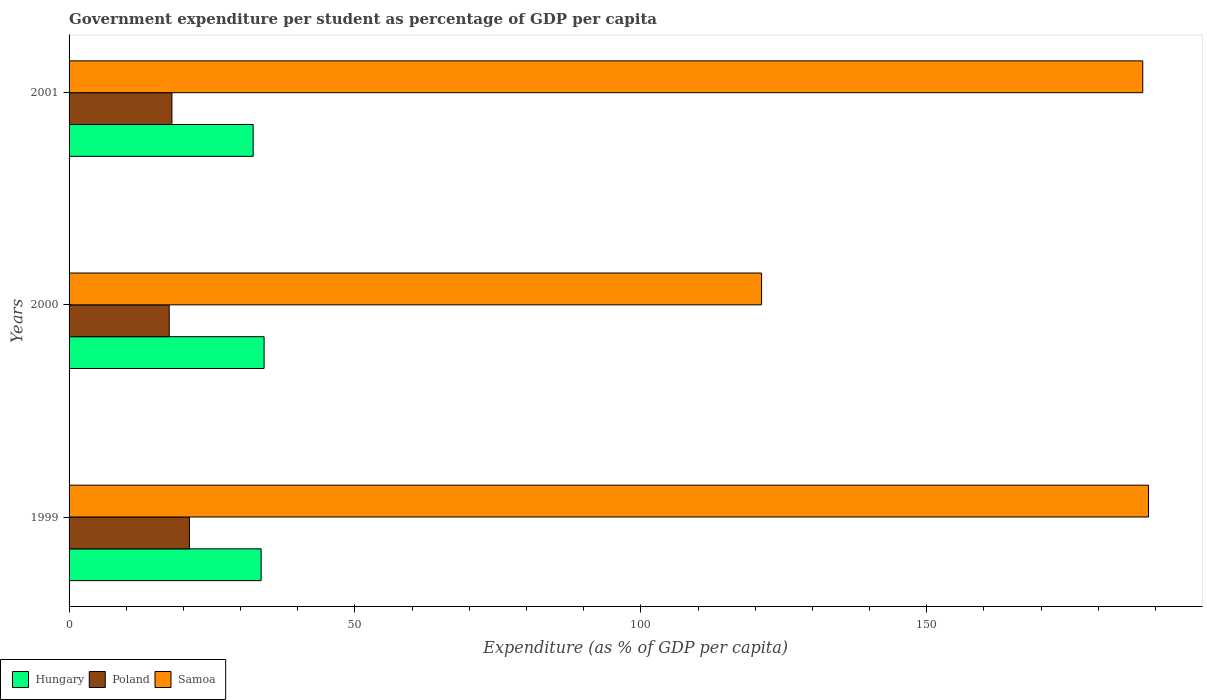Are the number of bars per tick equal to the number of legend labels?
Your answer should be compact. Yes. What is the percentage of expenditure per student in Poland in 2001?
Provide a succinct answer. 17.99. Across all years, what is the maximum percentage of expenditure per student in Hungary?
Offer a terse response. 34.11. Across all years, what is the minimum percentage of expenditure per student in Hungary?
Your answer should be compact. 32.2. In which year was the percentage of expenditure per student in Samoa maximum?
Ensure brevity in your answer.  1999. What is the total percentage of expenditure per student in Hungary in the graph?
Offer a very short reply. 99.89. What is the difference between the percentage of expenditure per student in Poland in 2000 and that in 2001?
Ensure brevity in your answer.  -0.48. What is the difference between the percentage of expenditure per student in Samoa in 2000 and the percentage of expenditure per student in Hungary in 1999?
Provide a short and direct response. 87.52. What is the average percentage of expenditure per student in Poland per year?
Provide a succinct answer. 18.85. In the year 2001, what is the difference between the percentage of expenditure per student in Hungary and percentage of expenditure per student in Poland?
Offer a terse response. 14.21. In how many years, is the percentage of expenditure per student in Hungary greater than 80 %?
Your answer should be very brief. 0. What is the ratio of the percentage of expenditure per student in Samoa in 1999 to that in 2001?
Make the answer very short. 1.01. What is the difference between the highest and the second highest percentage of expenditure per student in Poland?
Your answer should be compact. 3.06. What is the difference between the highest and the lowest percentage of expenditure per student in Hungary?
Make the answer very short. 1.91. What does the 1st bar from the bottom in 2001 represents?
Keep it short and to the point. Hungary. Is it the case that in every year, the sum of the percentage of expenditure per student in Hungary and percentage of expenditure per student in Poland is greater than the percentage of expenditure per student in Samoa?
Keep it short and to the point. No. Are all the bars in the graph horizontal?
Your answer should be compact. Yes. How many years are there in the graph?
Offer a very short reply. 3. What is the difference between two consecutive major ticks on the X-axis?
Make the answer very short. 50. Are the values on the major ticks of X-axis written in scientific E-notation?
Offer a very short reply. No. How many legend labels are there?
Provide a short and direct response. 3. How are the legend labels stacked?
Provide a succinct answer. Horizontal. What is the title of the graph?
Give a very brief answer. Government expenditure per student as percentage of GDP per capita. Does "Guinea" appear as one of the legend labels in the graph?
Make the answer very short. No. What is the label or title of the X-axis?
Offer a very short reply. Expenditure (as % of GDP per capita). What is the label or title of the Y-axis?
Provide a short and direct response. Years. What is the Expenditure (as % of GDP per capita) of Hungary in 1999?
Your response must be concise. 33.59. What is the Expenditure (as % of GDP per capita) of Poland in 1999?
Make the answer very short. 21.05. What is the Expenditure (as % of GDP per capita) in Samoa in 1999?
Make the answer very short. 188.78. What is the Expenditure (as % of GDP per capita) in Hungary in 2000?
Offer a very short reply. 34.11. What is the Expenditure (as % of GDP per capita) of Poland in 2000?
Your answer should be very brief. 17.51. What is the Expenditure (as % of GDP per capita) in Samoa in 2000?
Provide a short and direct response. 121.11. What is the Expenditure (as % of GDP per capita) in Hungary in 2001?
Your answer should be very brief. 32.2. What is the Expenditure (as % of GDP per capita) in Poland in 2001?
Offer a very short reply. 17.99. What is the Expenditure (as % of GDP per capita) in Samoa in 2001?
Offer a very short reply. 187.77. Across all years, what is the maximum Expenditure (as % of GDP per capita) of Hungary?
Keep it short and to the point. 34.11. Across all years, what is the maximum Expenditure (as % of GDP per capita) in Poland?
Your answer should be very brief. 21.05. Across all years, what is the maximum Expenditure (as % of GDP per capita) in Samoa?
Offer a very short reply. 188.78. Across all years, what is the minimum Expenditure (as % of GDP per capita) in Hungary?
Provide a short and direct response. 32.2. Across all years, what is the minimum Expenditure (as % of GDP per capita) of Poland?
Your answer should be very brief. 17.51. Across all years, what is the minimum Expenditure (as % of GDP per capita) of Samoa?
Your response must be concise. 121.11. What is the total Expenditure (as % of GDP per capita) of Hungary in the graph?
Your answer should be compact. 99.89. What is the total Expenditure (as % of GDP per capita) in Poland in the graph?
Give a very brief answer. 56.55. What is the total Expenditure (as % of GDP per capita) of Samoa in the graph?
Provide a short and direct response. 497.66. What is the difference between the Expenditure (as % of GDP per capita) in Hungary in 1999 and that in 2000?
Make the answer very short. -0.52. What is the difference between the Expenditure (as % of GDP per capita) of Poland in 1999 and that in 2000?
Keep it short and to the point. 3.54. What is the difference between the Expenditure (as % of GDP per capita) in Samoa in 1999 and that in 2000?
Keep it short and to the point. 67.67. What is the difference between the Expenditure (as % of GDP per capita) in Hungary in 1999 and that in 2001?
Your response must be concise. 1.4. What is the difference between the Expenditure (as % of GDP per capita) in Poland in 1999 and that in 2001?
Your response must be concise. 3.06. What is the difference between the Expenditure (as % of GDP per capita) of Samoa in 1999 and that in 2001?
Give a very brief answer. 1.01. What is the difference between the Expenditure (as % of GDP per capita) of Hungary in 2000 and that in 2001?
Provide a short and direct response. 1.91. What is the difference between the Expenditure (as % of GDP per capita) of Poland in 2000 and that in 2001?
Make the answer very short. -0.48. What is the difference between the Expenditure (as % of GDP per capita) in Samoa in 2000 and that in 2001?
Offer a very short reply. -66.66. What is the difference between the Expenditure (as % of GDP per capita) in Hungary in 1999 and the Expenditure (as % of GDP per capita) in Poland in 2000?
Your answer should be very brief. 16.08. What is the difference between the Expenditure (as % of GDP per capita) in Hungary in 1999 and the Expenditure (as % of GDP per capita) in Samoa in 2000?
Offer a very short reply. -87.52. What is the difference between the Expenditure (as % of GDP per capita) in Poland in 1999 and the Expenditure (as % of GDP per capita) in Samoa in 2000?
Your response must be concise. -100.05. What is the difference between the Expenditure (as % of GDP per capita) of Hungary in 1999 and the Expenditure (as % of GDP per capita) of Poland in 2001?
Give a very brief answer. 15.6. What is the difference between the Expenditure (as % of GDP per capita) in Hungary in 1999 and the Expenditure (as % of GDP per capita) in Samoa in 2001?
Give a very brief answer. -154.18. What is the difference between the Expenditure (as % of GDP per capita) of Poland in 1999 and the Expenditure (as % of GDP per capita) of Samoa in 2001?
Give a very brief answer. -166.72. What is the difference between the Expenditure (as % of GDP per capita) in Hungary in 2000 and the Expenditure (as % of GDP per capita) in Poland in 2001?
Make the answer very short. 16.12. What is the difference between the Expenditure (as % of GDP per capita) in Hungary in 2000 and the Expenditure (as % of GDP per capita) in Samoa in 2001?
Ensure brevity in your answer.  -153.66. What is the difference between the Expenditure (as % of GDP per capita) of Poland in 2000 and the Expenditure (as % of GDP per capita) of Samoa in 2001?
Provide a succinct answer. -170.26. What is the average Expenditure (as % of GDP per capita) of Hungary per year?
Keep it short and to the point. 33.3. What is the average Expenditure (as % of GDP per capita) of Poland per year?
Keep it short and to the point. 18.85. What is the average Expenditure (as % of GDP per capita) of Samoa per year?
Provide a succinct answer. 165.89. In the year 1999, what is the difference between the Expenditure (as % of GDP per capita) in Hungary and Expenditure (as % of GDP per capita) in Poland?
Provide a succinct answer. 12.54. In the year 1999, what is the difference between the Expenditure (as % of GDP per capita) of Hungary and Expenditure (as % of GDP per capita) of Samoa?
Provide a short and direct response. -155.19. In the year 1999, what is the difference between the Expenditure (as % of GDP per capita) of Poland and Expenditure (as % of GDP per capita) of Samoa?
Keep it short and to the point. -167.73. In the year 2000, what is the difference between the Expenditure (as % of GDP per capita) of Hungary and Expenditure (as % of GDP per capita) of Poland?
Offer a very short reply. 16.59. In the year 2000, what is the difference between the Expenditure (as % of GDP per capita) of Hungary and Expenditure (as % of GDP per capita) of Samoa?
Ensure brevity in your answer.  -87. In the year 2000, what is the difference between the Expenditure (as % of GDP per capita) of Poland and Expenditure (as % of GDP per capita) of Samoa?
Make the answer very short. -103.59. In the year 2001, what is the difference between the Expenditure (as % of GDP per capita) in Hungary and Expenditure (as % of GDP per capita) in Poland?
Your answer should be compact. 14.21. In the year 2001, what is the difference between the Expenditure (as % of GDP per capita) of Hungary and Expenditure (as % of GDP per capita) of Samoa?
Your response must be concise. -155.57. In the year 2001, what is the difference between the Expenditure (as % of GDP per capita) of Poland and Expenditure (as % of GDP per capita) of Samoa?
Your answer should be compact. -169.78. What is the ratio of the Expenditure (as % of GDP per capita) of Hungary in 1999 to that in 2000?
Offer a very short reply. 0.98. What is the ratio of the Expenditure (as % of GDP per capita) of Poland in 1999 to that in 2000?
Give a very brief answer. 1.2. What is the ratio of the Expenditure (as % of GDP per capita) in Samoa in 1999 to that in 2000?
Ensure brevity in your answer.  1.56. What is the ratio of the Expenditure (as % of GDP per capita) in Hungary in 1999 to that in 2001?
Offer a terse response. 1.04. What is the ratio of the Expenditure (as % of GDP per capita) of Poland in 1999 to that in 2001?
Keep it short and to the point. 1.17. What is the ratio of the Expenditure (as % of GDP per capita) in Samoa in 1999 to that in 2001?
Your response must be concise. 1.01. What is the ratio of the Expenditure (as % of GDP per capita) in Hungary in 2000 to that in 2001?
Make the answer very short. 1.06. What is the ratio of the Expenditure (as % of GDP per capita) of Poland in 2000 to that in 2001?
Give a very brief answer. 0.97. What is the ratio of the Expenditure (as % of GDP per capita) in Samoa in 2000 to that in 2001?
Offer a very short reply. 0.65. What is the difference between the highest and the second highest Expenditure (as % of GDP per capita) in Hungary?
Make the answer very short. 0.52. What is the difference between the highest and the second highest Expenditure (as % of GDP per capita) in Poland?
Your response must be concise. 3.06. What is the difference between the highest and the second highest Expenditure (as % of GDP per capita) of Samoa?
Offer a terse response. 1.01. What is the difference between the highest and the lowest Expenditure (as % of GDP per capita) of Hungary?
Provide a succinct answer. 1.91. What is the difference between the highest and the lowest Expenditure (as % of GDP per capita) in Poland?
Keep it short and to the point. 3.54. What is the difference between the highest and the lowest Expenditure (as % of GDP per capita) of Samoa?
Give a very brief answer. 67.67. 